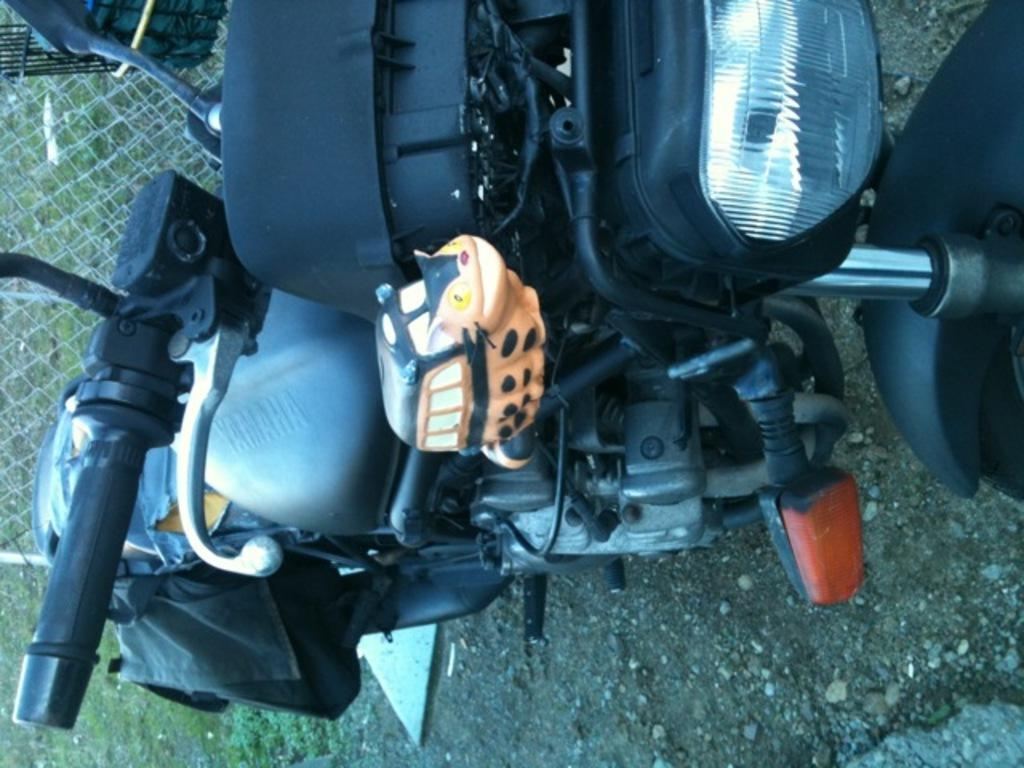What is the main subject of the image? The main subject of the image is a vehicle. What is the status of the vehicle in the image? The vehicle is parked. Are there any additional objects attached to the vehicle? Yes, there is a toy attached to the vehicle. What type of structure can be seen in the image? There is a boundary grill in the image. What is the chance of destruction caused by the vehicle in the image? There is no chance of destruction caused by the vehicle in the image, as it is parked and not in motion. 